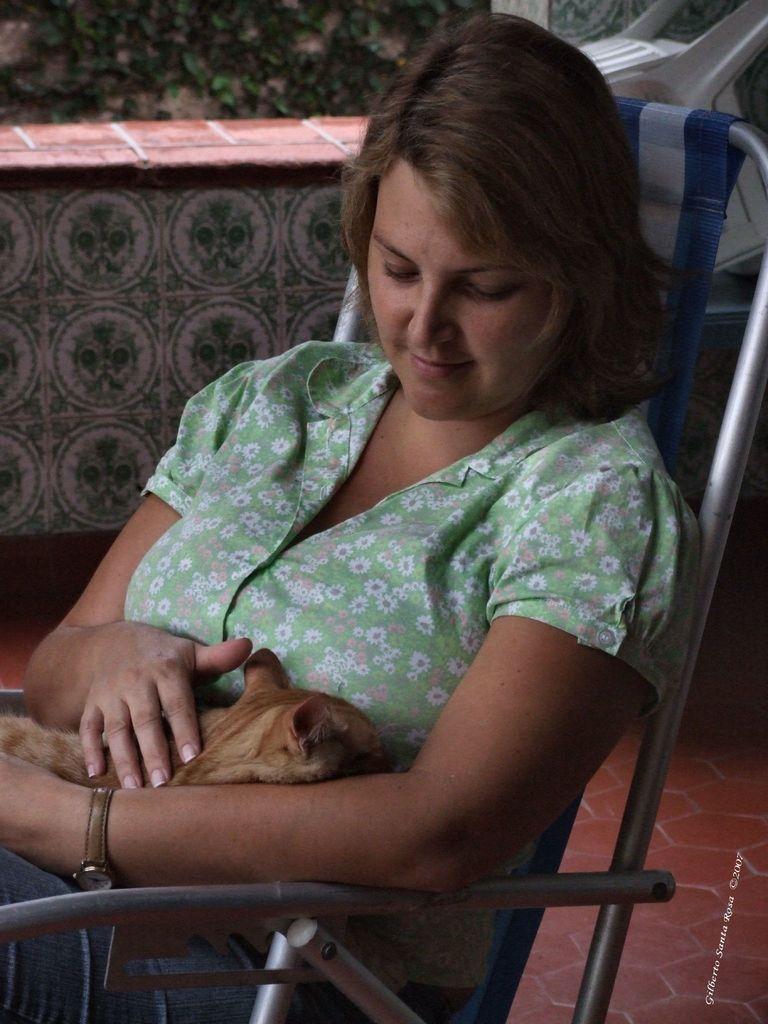Can you describe this image briefly? In the picture we can see a woman holding a cat and sitting on the chair. She is wearing a green dress, in the back side we can see a wall and some plants. 